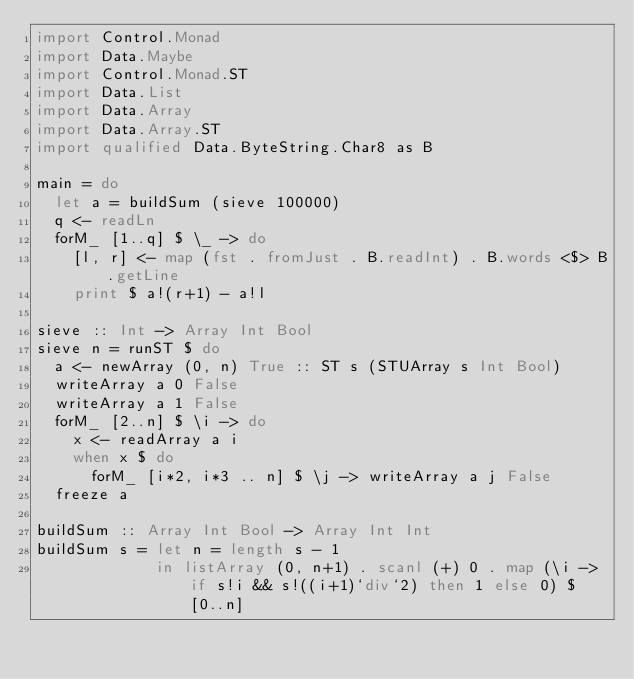Convert code to text. <code><loc_0><loc_0><loc_500><loc_500><_Haskell_>import Control.Monad
import Data.Maybe
import Control.Monad.ST
import Data.List
import Data.Array
import Data.Array.ST
import qualified Data.ByteString.Char8 as B

main = do
  let a = buildSum (sieve 100000)
  q <- readLn
  forM_ [1..q] $ \_ -> do
    [l, r] <- map (fst . fromJust . B.readInt) . B.words <$> B.getLine
    print $ a!(r+1) - a!l

sieve :: Int -> Array Int Bool
sieve n = runST $ do
  a <- newArray (0, n) True :: ST s (STUArray s Int Bool)
  writeArray a 0 False
  writeArray a 1 False
  forM_ [2..n] $ \i -> do
    x <- readArray a i
    when x $ do
      forM_ [i*2, i*3 .. n] $ \j -> writeArray a j False
  freeze a

buildSum :: Array Int Bool -> Array Int Int
buildSum s = let n = length s - 1
             in listArray (0, n+1) . scanl (+) 0 . map (\i -> if s!i && s!((i+1)`div`2) then 1 else 0) $ [0..n]
</code> 